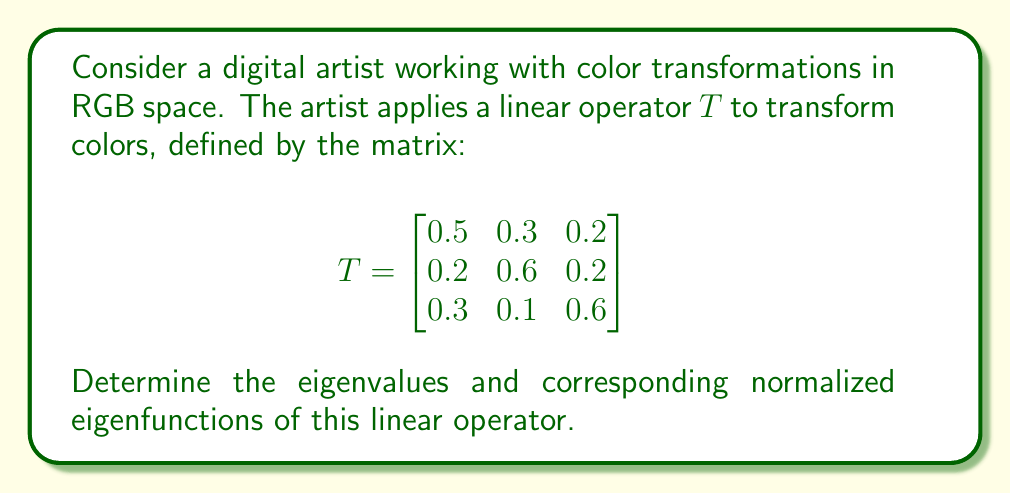Can you solve this math problem? To find the eigenvalues and eigenfunctions of the linear operator $T$, we follow these steps:

1) First, we need to find the eigenvalues by solving the characteristic equation:

   $$\det(T - \lambda I) = 0$$

   Where $I$ is the $3 \times 3$ identity matrix and $\lambda$ represents the eigenvalues.

2) Expanding the determinant:

   $$\begin{vmatrix}
   0.5 - \lambda & 0.3 & 0.2 \\
   0.2 & 0.6 - \lambda & 0.2 \\
   0.3 & 0.1 & 0.6 - \lambda
   \end{vmatrix} = 0$$

3) This yields the characteristic polynomial:

   $$-\lambda^3 + 1.7\lambda^2 - 0.86\lambda + 0.13 = 0$$

4) Solving this equation (using numerical methods or a computer algebra system), we get the eigenvalues:

   $\lambda_1 \approx 1$, $\lambda_2 \approx 0.5$, $\lambda_3 \approx 0.2$

5) For each eigenvalue, we find the corresponding eigenfunction by solving $(T - \lambda I)v = 0$:

   For $\lambda_1 = 1$:
   $$\begin{bmatrix}
   -0.5 & 0.3 & 0.2 \\
   0.2 & -0.4 & 0.2 \\
   0.3 & 0.1 & -0.4
   \end{bmatrix} \begin{bmatrix} v_1 \\ v_2 \\ v_3 \end{bmatrix} = \begin{bmatrix} 0 \\ 0 \\ 0 \end{bmatrix}$$

   Solving this system gives us $v_1 = (1, 1, 1)^T$

   For $\lambda_2 = 0.5$:
   $$\begin{bmatrix}
   0 & 0.3 & 0.2 \\
   0.2 & 0.1 & 0.2 \\
   0.3 & 0.1 & 0.1
   \end{bmatrix} \begin{bmatrix} v_2 \\ v_2 \\ v_3 \end{bmatrix} = \begin{bmatrix} 0 \\ 0 \\ 0 \end{bmatrix}$$

   Solving this system gives us $v_2 = (-1, 1, 0)^T$

   For $\lambda_3 = 0.2$:
   $$\begin{bmatrix}
   0.3 & 0.3 & 0.2 \\
   0.2 & 0.4 & 0.2 \\
   0.3 & 0.1 & 0.4
   \end{bmatrix} \begin{bmatrix} v_1 \\ v_2 \\ v_3 \end{bmatrix} = \begin{bmatrix} 0 \\ 0 \\ 0 \end{bmatrix}$$

   Solving this system gives us $v_3 = (1, -1, -1)^T$

6) Finally, we normalize these eigenvectors to get the normalized eigenfunctions:

   $u_1 = \frac{1}{\sqrt{3}}(1, 1, 1)^T$
   $u_2 = \frac{1}{\sqrt{2}}(-1, 1, 0)^T$
   $u_3 = \frac{1}{\sqrt{3}}(1, -1, -1)^T$
Answer: The eigenvalues and corresponding normalized eigenfunctions of the linear operator $T$ are:

$\lambda_1 = 1$, $u_1 = \frac{1}{\sqrt{3}}(1, 1, 1)^T$
$\lambda_2 = 0.5$, $u_2 = \frac{1}{\sqrt{2}}(-1, 1, 0)^T$
$\lambda_3 = 0.2$, $u_3 = \frac{1}{\sqrt{3}}(1, -1, -1)^T$ 